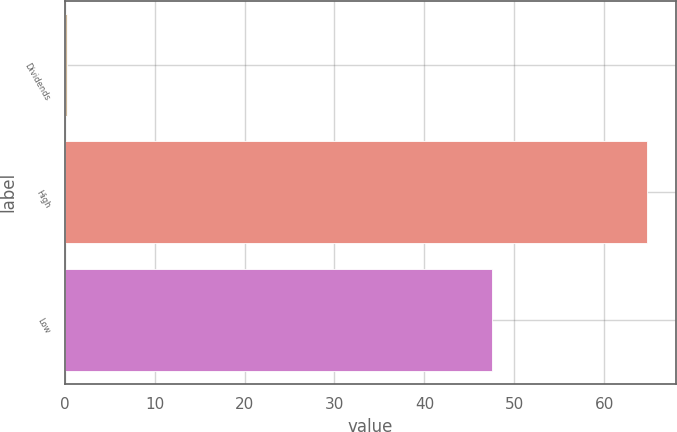<chart> <loc_0><loc_0><loc_500><loc_500><bar_chart><fcel>Dividends<fcel>High<fcel>Low<nl><fcel>0.27<fcel>64.75<fcel>47.47<nl></chart> 